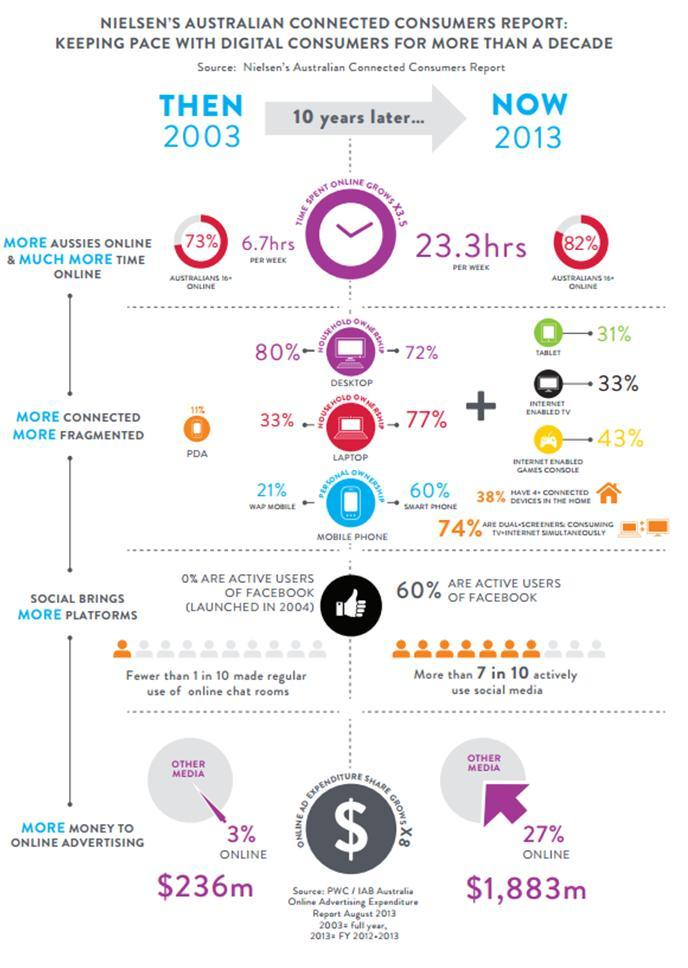By how many hours did the time spent online increase in 10 years?
Answer the question with a short phrase. 16.6 hrs PER WEEK What percent of people are not active users of Facebook? 40% By how much did money spent on online advertising increase from 2003 to 2010? $1,647 m By how much did the percentage of Australians online grow from 2003 to 2013? 9% Did household ownership of desktop increase or decrease in 2013? decrease Which type of devices are beIng increasingly connected to internet? INTERNET ENABLED GAMES CONSOLE 